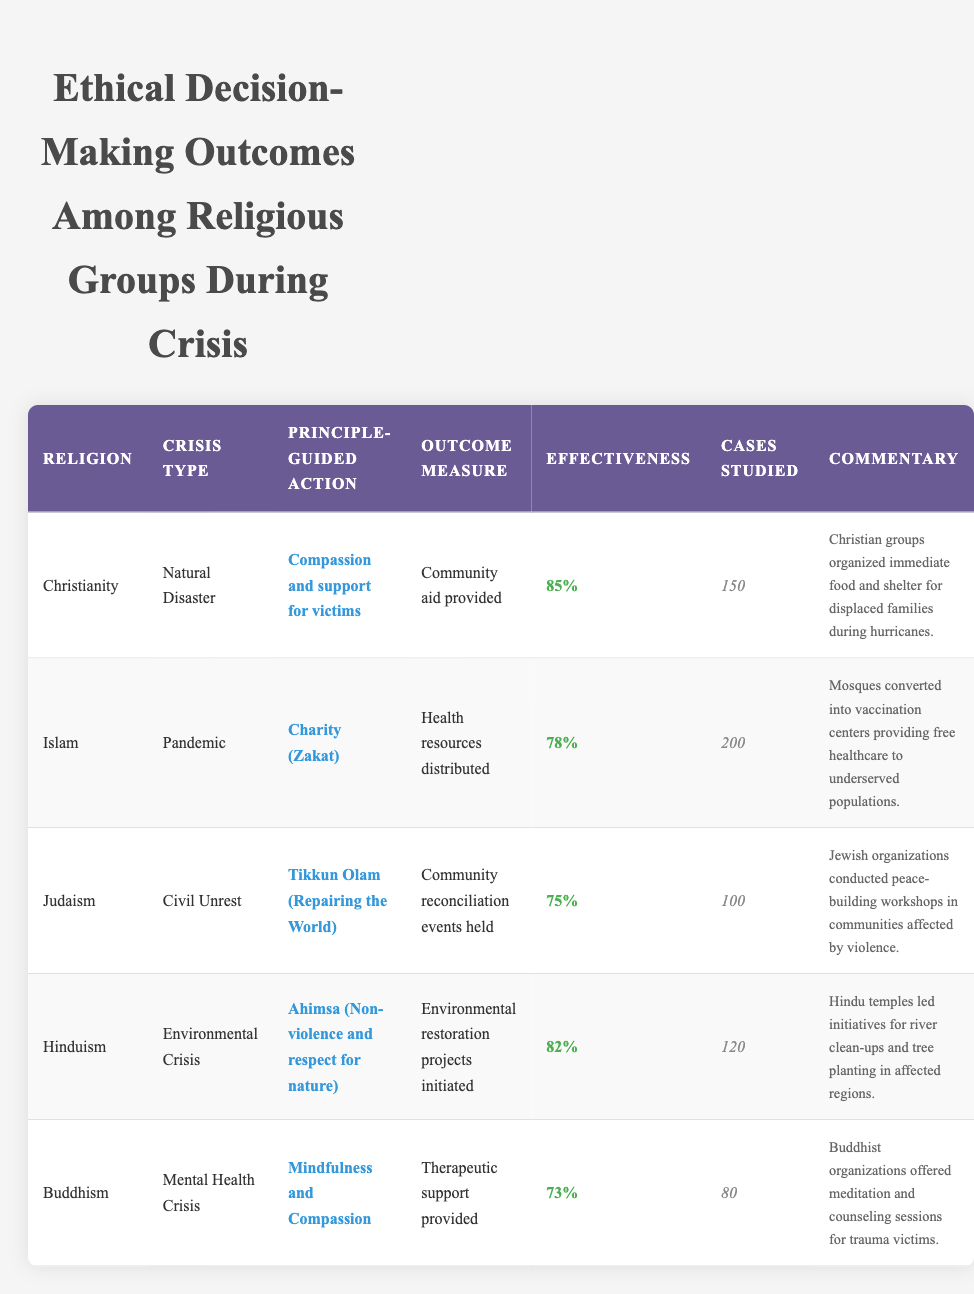What was the percentage effectiveness of ethical decision-making outcomes for Christianity in response to a natural disaster? The table shows that the percentage effectiveness for Christianity during a natural disaster is 85%.
Answer: 85% Which religious group had the lowest effectiveness in addressing a crisis? The table indicates that Buddhism had the lowest effectiveness at 73%.
Answer: Buddhism What is the average effectiveness of ethical decision-making outcomes among the five religious groups? The effectiveness percentages for the groups are 85, 78, 75, 82, and 73. The sum of these percentages is (85 + 78 + 75 + 82 + 73) = 393. Dividing by the number of groups (5) gives an average of 393 / 5 = 78.6.
Answer: 78.6 Did Hinduism address an environmental crisis through its ethical principles? According to the table, Hinduism did address an environmental crisis, guided by the principle of Ahimsa, initiating environmental restoration projects.
Answer: Yes How many cases were studied for the Islam group's response to the pandemic? In the table, it states that 200 cases were studied for the Islam group during the pandemic.
Answer: 200 What principle-guided action did Judaism utilize during civil unrest? The table shows that Judaism utilized the principle of Tikkun Olam (Repairing the World) during civil unrest.
Answer: Tikkun Olam If we consider the highest and lowest effectiveness percentages, what is the difference? The highest percentage is 85% for Christianity, and the lowest is 73% for Buddhism. The difference is calculated as 85 - 73 = 12.
Answer: 12 What outcome measure was associated with the ethical response of Hinduism to an environmental crisis? The table specifies that the outcome measure associated with Hinduism's response was environmental restoration projects initiated.
Answer: Environmental restoration projects initiated Which religious group organized peace-building workshops during civil unrest, and what was their effectiveness percentage? The table indicates that Judaism organized peace-building workshops during civil unrest, with an effectiveness percentage of 75%.
Answer: Judaism, 75% 